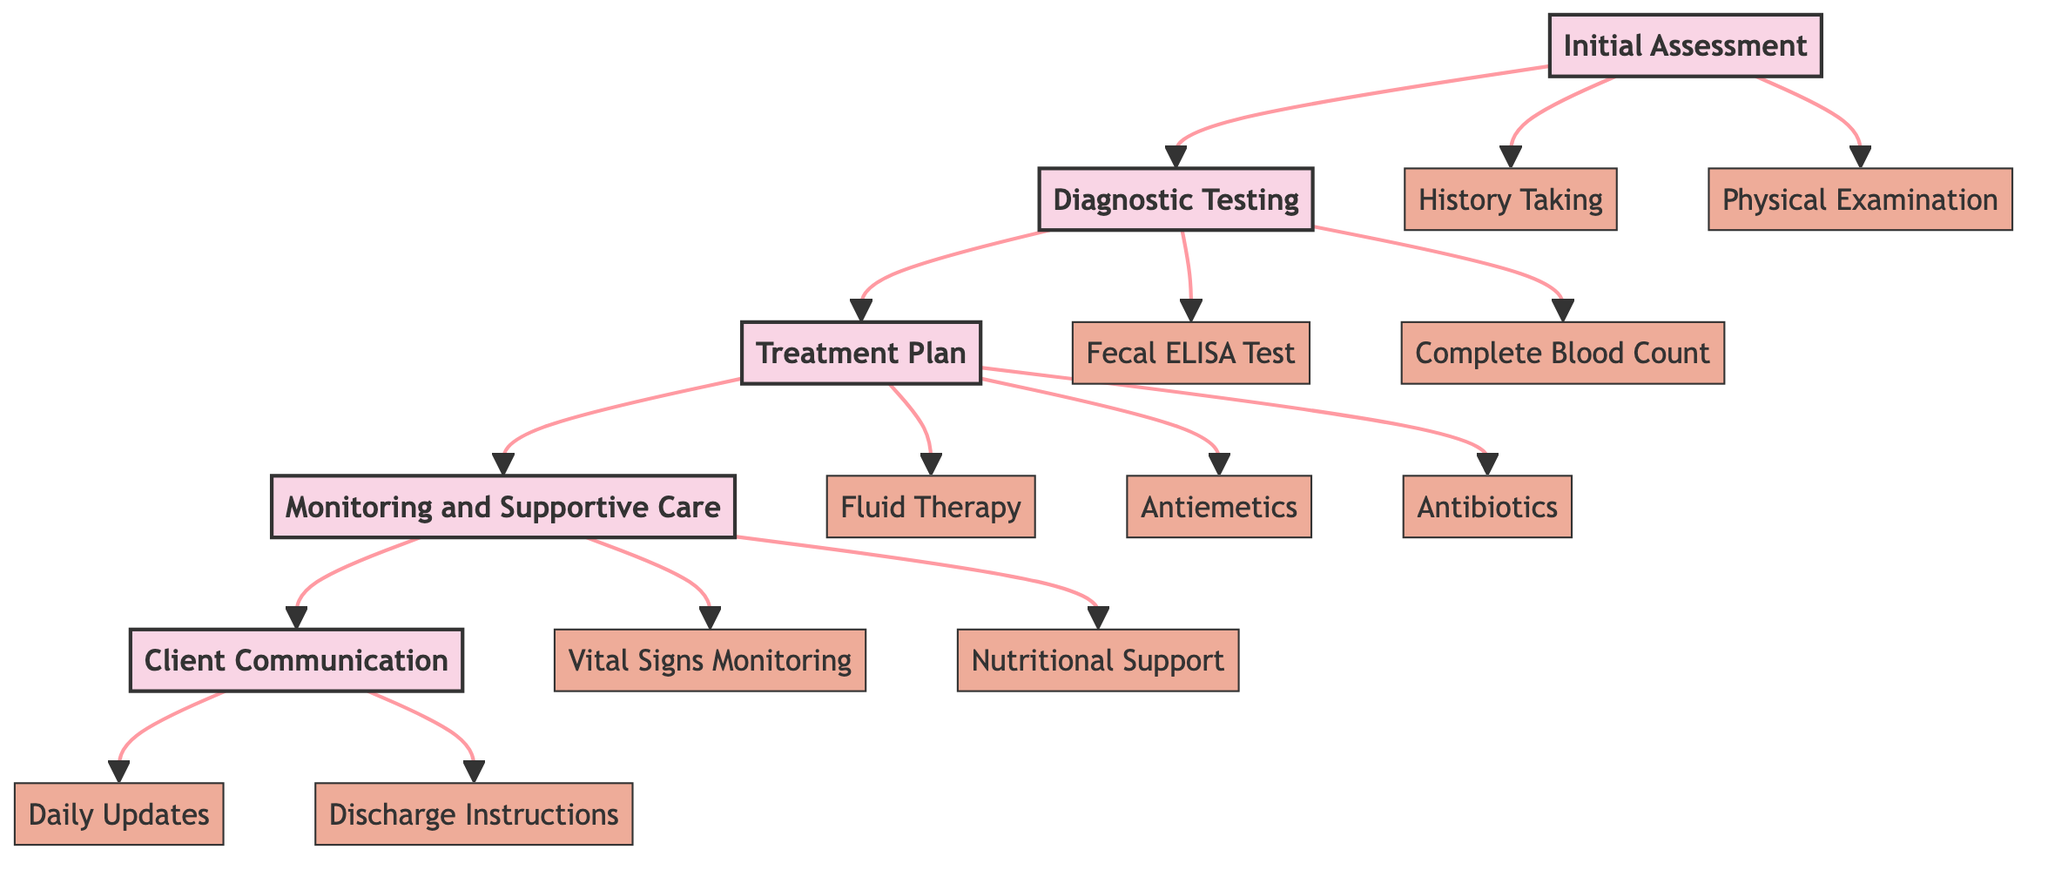What is the first step in the workflow? The first step in the workflow, as indicated by the top node of the diagram, is "Initial Assessment." It is the starting point of the clinical case management for a canine parvovirus patient.
Answer: Initial Assessment How many main nodes are present in the diagram? The diagram consists of five main nodes, which are "Initial Assessment," "Diagnostic Testing," "Treatment Plan," "Monitoring and Supportive Care," and "Client Communication." Each node represents a specific phase in the clinical workflow.
Answer: 5 What type of test is performed in the "Diagnostic Testing" phase? The "Diagnostic Testing" phase includes "Fecal ELISA Test," which is an enzyme-linked immunosorbent assay to detect Parvovirus in stool. This is a specific type of test categorized under this phase.
Answer: Fecal ELISA Test What follows the "Treatment Plan" step? The node that follows "Treatment Plan" in the workflow is "Monitoring and Supportive Care," indicating that after developing a treatment strategy, continuous observation and supportive interventions are necessary.
Answer: Monitoring and Supportive Care Which node is associated with "Daily Updates"? "Daily Updates" is a sub-element under the "Client Communication" main node. This indicates that client communication is an important part of the workflow, with a focus on providing daily health updates to the pet owner.
Answer: Client Communication What are two sub-elements of the "Monitoring and Supportive Care"? The two sub-elements identified under "Monitoring and Supportive Care" are "Vital Signs Monitoring" and "Nutritional Support." These components highlight the importance of tracking the patient's health condition and providing proper nutrition during recovery.
Answer: Vital Signs Monitoring, Nutritional Support What is the purpose of the "Fluid Therapy" in the treatment plan? "Fluid Therapy" is aimed at administering intravenous fluids to maintain hydration and electrolyte balance, which is critical for the recovery of a canine patient with parvovirus. This specific treatment is essential for managing the effects of the virus.
Answer: Maintain hydration and electrolyte balance How is the owner kept informed about the treatment process? The owner is kept informed through the "Client Communication" phase, which includes elements like "Daily Updates" and "Discharge Instructions" to provide essential information about their pet's status and care guidelines.
Answer: Client Communication Which test checks for leukopenia, anemia, and electrolyte imbalances? The test that checks for these conditions is the "Complete Blood Count (CBC)," which is part of the diagnostic testing to confirm a canine parvovirus diagnosis. This test is crucial for evaluating the patient's overall health status.
Answer: Complete Blood Count 